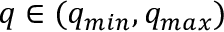Convert formula to latex. <formula><loc_0><loc_0><loc_500><loc_500>q \in ( q _ { \min } , q _ { \max } )</formula> 